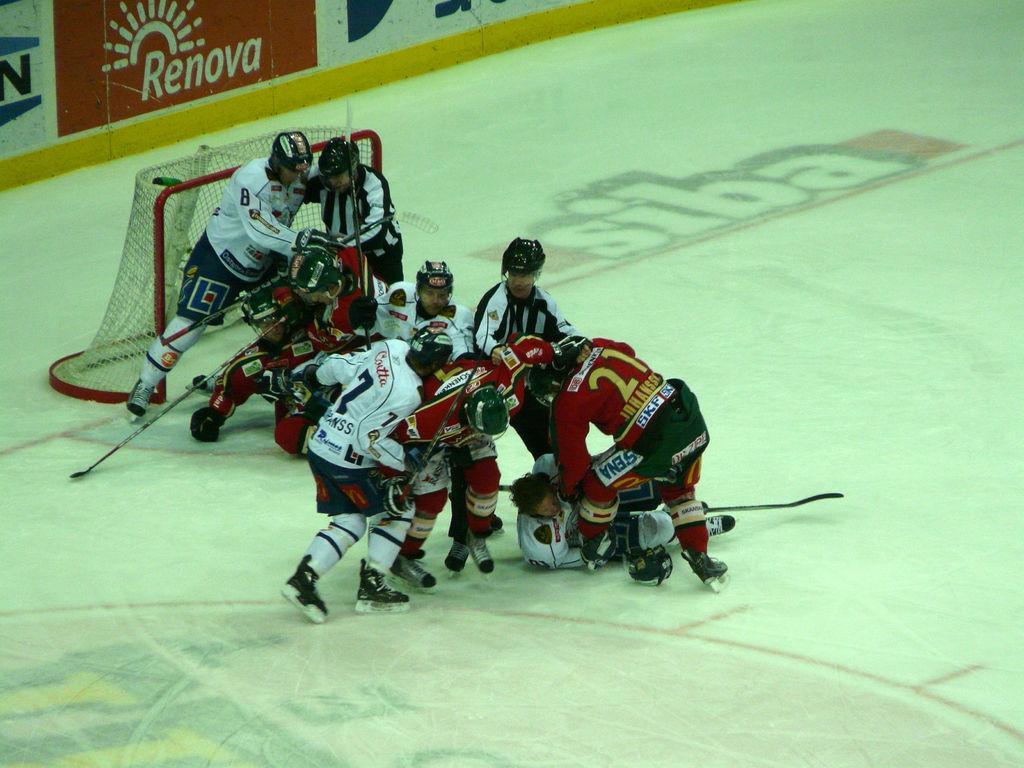Can you describe this image briefly? In this image on the ground there are few players. They are holding sticks, they are wearing skate shoes. On the ground there is ice. This is the goal post. Here there are banners. 